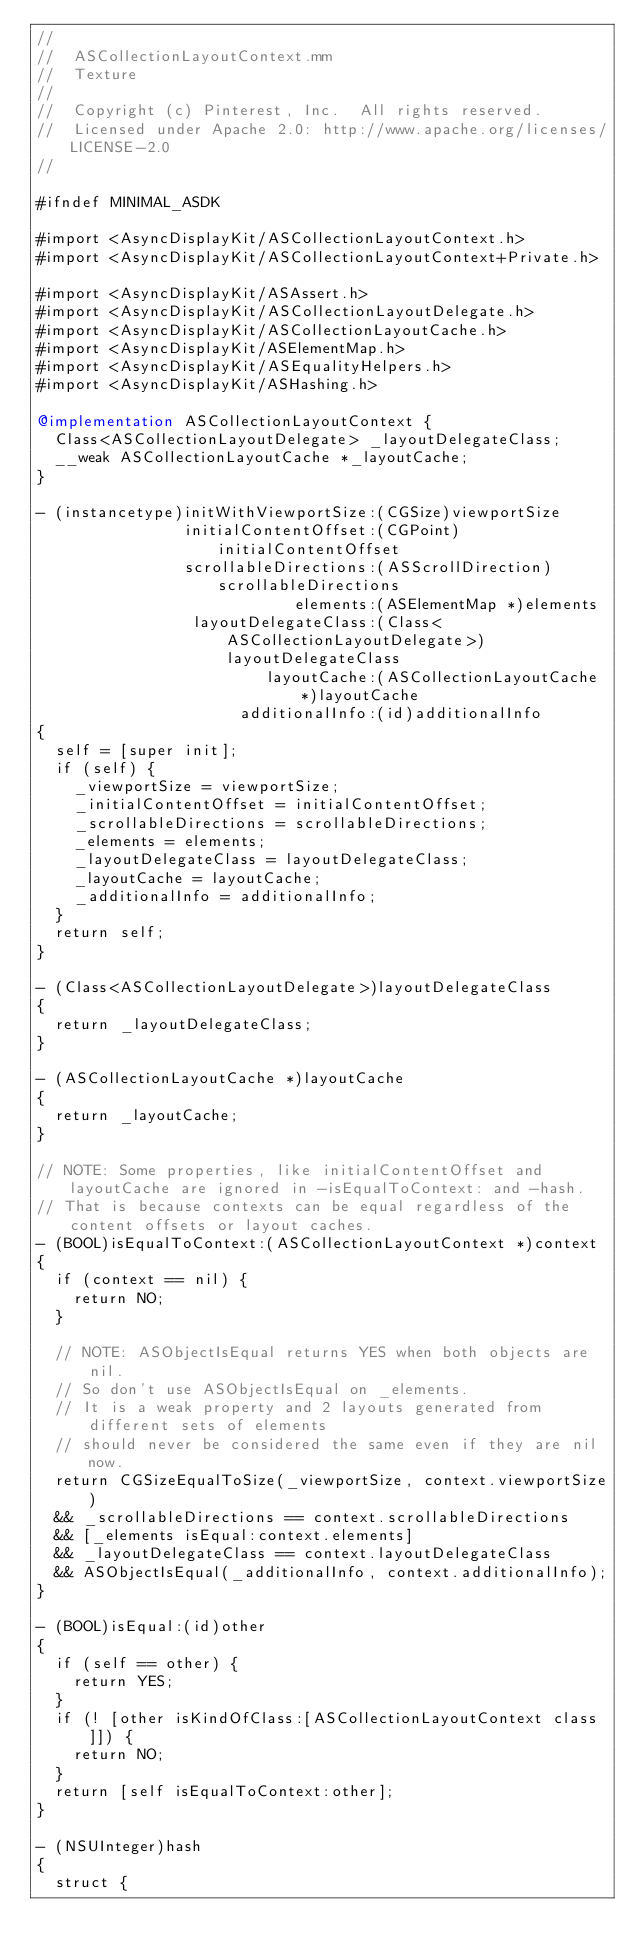Convert code to text. <code><loc_0><loc_0><loc_500><loc_500><_ObjectiveC_>//
//  ASCollectionLayoutContext.mm
//  Texture
//
//  Copyright (c) Pinterest, Inc.  All rights reserved.
//  Licensed under Apache 2.0: http://www.apache.org/licenses/LICENSE-2.0
//

#ifndef MINIMAL_ASDK

#import <AsyncDisplayKit/ASCollectionLayoutContext.h>
#import <AsyncDisplayKit/ASCollectionLayoutContext+Private.h>

#import <AsyncDisplayKit/ASAssert.h>
#import <AsyncDisplayKit/ASCollectionLayoutDelegate.h>
#import <AsyncDisplayKit/ASCollectionLayoutCache.h>
#import <AsyncDisplayKit/ASElementMap.h>
#import <AsyncDisplayKit/ASEqualityHelpers.h>
#import <AsyncDisplayKit/ASHashing.h>

@implementation ASCollectionLayoutContext {
  Class<ASCollectionLayoutDelegate> _layoutDelegateClass;
  __weak ASCollectionLayoutCache *_layoutCache;
}

- (instancetype)initWithViewportSize:(CGSize)viewportSize
                initialContentOffset:(CGPoint)initialContentOffset
                scrollableDirections:(ASScrollDirection)scrollableDirections
                            elements:(ASElementMap *)elements
                 layoutDelegateClass:(Class<ASCollectionLayoutDelegate>)layoutDelegateClass
                         layoutCache:(ASCollectionLayoutCache *)layoutCache
                      additionalInfo:(id)additionalInfo
{
  self = [super init];
  if (self) {
    _viewportSize = viewportSize;
    _initialContentOffset = initialContentOffset;
    _scrollableDirections = scrollableDirections;
    _elements = elements;
    _layoutDelegateClass = layoutDelegateClass;
    _layoutCache = layoutCache;
    _additionalInfo = additionalInfo;
  }
  return self;
}

- (Class<ASCollectionLayoutDelegate>)layoutDelegateClass
{
  return _layoutDelegateClass;
}

- (ASCollectionLayoutCache *)layoutCache
{
  return _layoutCache;
}

// NOTE: Some properties, like initialContentOffset and layoutCache are ignored in -isEqualToContext: and -hash.
// That is because contexts can be equal regardless of the content offsets or layout caches.
- (BOOL)isEqualToContext:(ASCollectionLayoutContext *)context
{
  if (context == nil) {
    return NO;
  }

  // NOTE: ASObjectIsEqual returns YES when both objects are nil.
  // So don't use ASObjectIsEqual on _elements.
  // It is a weak property and 2 layouts generated from different sets of elements
  // should never be considered the same even if they are nil now.
  return CGSizeEqualToSize(_viewportSize, context.viewportSize)
  && _scrollableDirections == context.scrollableDirections
  && [_elements isEqual:context.elements]
  && _layoutDelegateClass == context.layoutDelegateClass
  && ASObjectIsEqual(_additionalInfo, context.additionalInfo);
}

- (BOOL)isEqual:(id)other
{
  if (self == other) {
    return YES;
  }
  if (! [other isKindOfClass:[ASCollectionLayoutContext class]]) {
    return NO;
  }
  return [self isEqualToContext:other];
}

- (NSUInteger)hash
{
  struct {</code> 